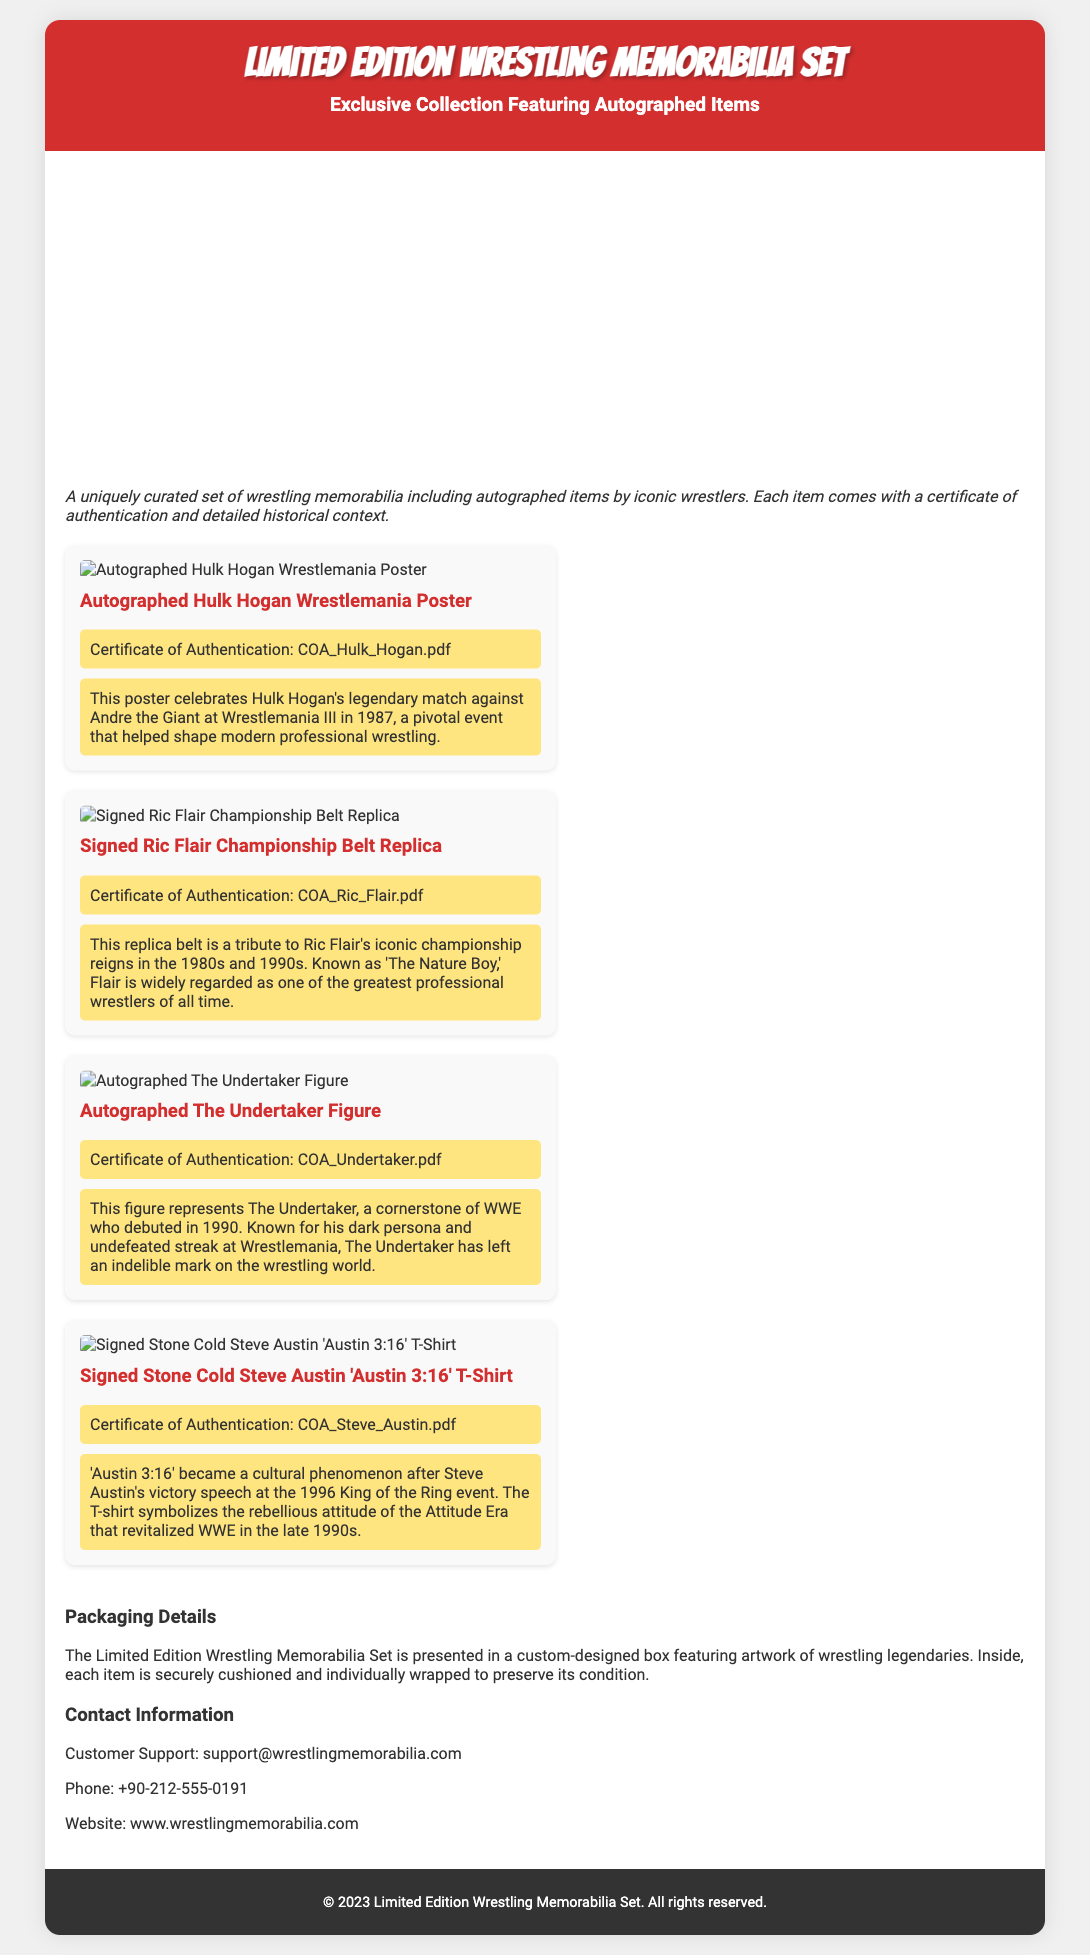What is the title of the collection? The title is prominently displayed at the top of the document, indicating the name of the product.
Answer: Limited Edition Wrestling Memorabilia Set Who is featured on the autographed Wrestlemania poster? The document specifies that the poster is autographed by a well-known wrestler associated with Wrestlemania.
Answer: Hulk Hogan What does the 'Austin 3:16' T-shirt symbolize? The document provides details on the significance of the T-shirt within wrestling history, particularly during a specific era.
Answer: Rebellious attitude of the Attitude Era How many items are included in this Limited Edition set? The document shows four distinct items listed under the collection, each with descriptions.
Answer: Four Which item has the certificate labeled COA_Ric_Flair.pdf? The specific item's authentication certificate is named in the document, allowing for easy identification.
Answer: Signed Ric Flair Championship Belt Replica When did The Undertaker debut in WWE? Historical context associated with the item details the debut year of this iconic wrestler.
Answer: 1990 What type of packaging is used for the memorabilia set? The document describes how the memorabilia is presented, highlighting the design and protective measures.
Answer: Custom-designed box Who can be contacted for customer support? The document lists a contact method for customer inquiries, specifically related to support for this product.
Answer: support@wrestlingmemorabilia.com 